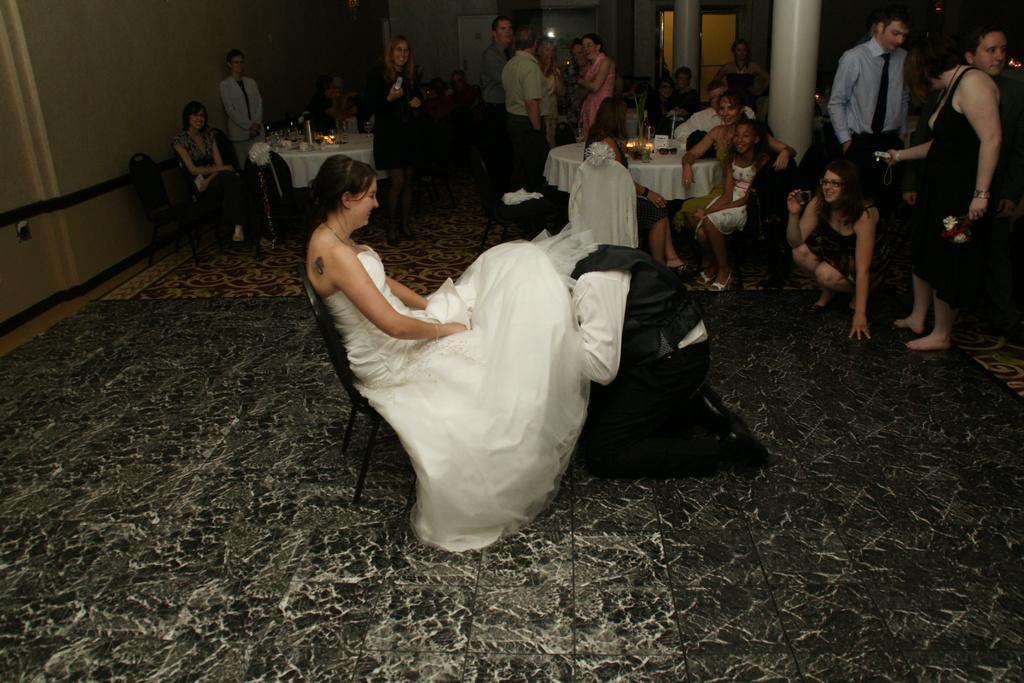Could you give a brief overview of what you see in this image? In the center of the image we can see a woman wearing white frock and sitting on the chair which is on the floor. We can also see a man. In the background we can see a few people standing. We can also see some people sitting on the chairs in front of the table which is covered with the white cloth. We can also see the pillars and also the wall. On the table we can see a bottle and some candles. 